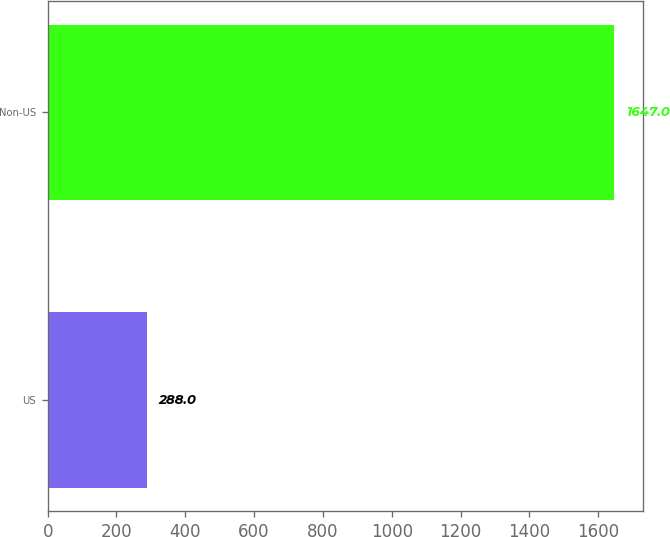<chart> <loc_0><loc_0><loc_500><loc_500><bar_chart><fcel>US<fcel>Non-US<nl><fcel>288<fcel>1647<nl></chart> 